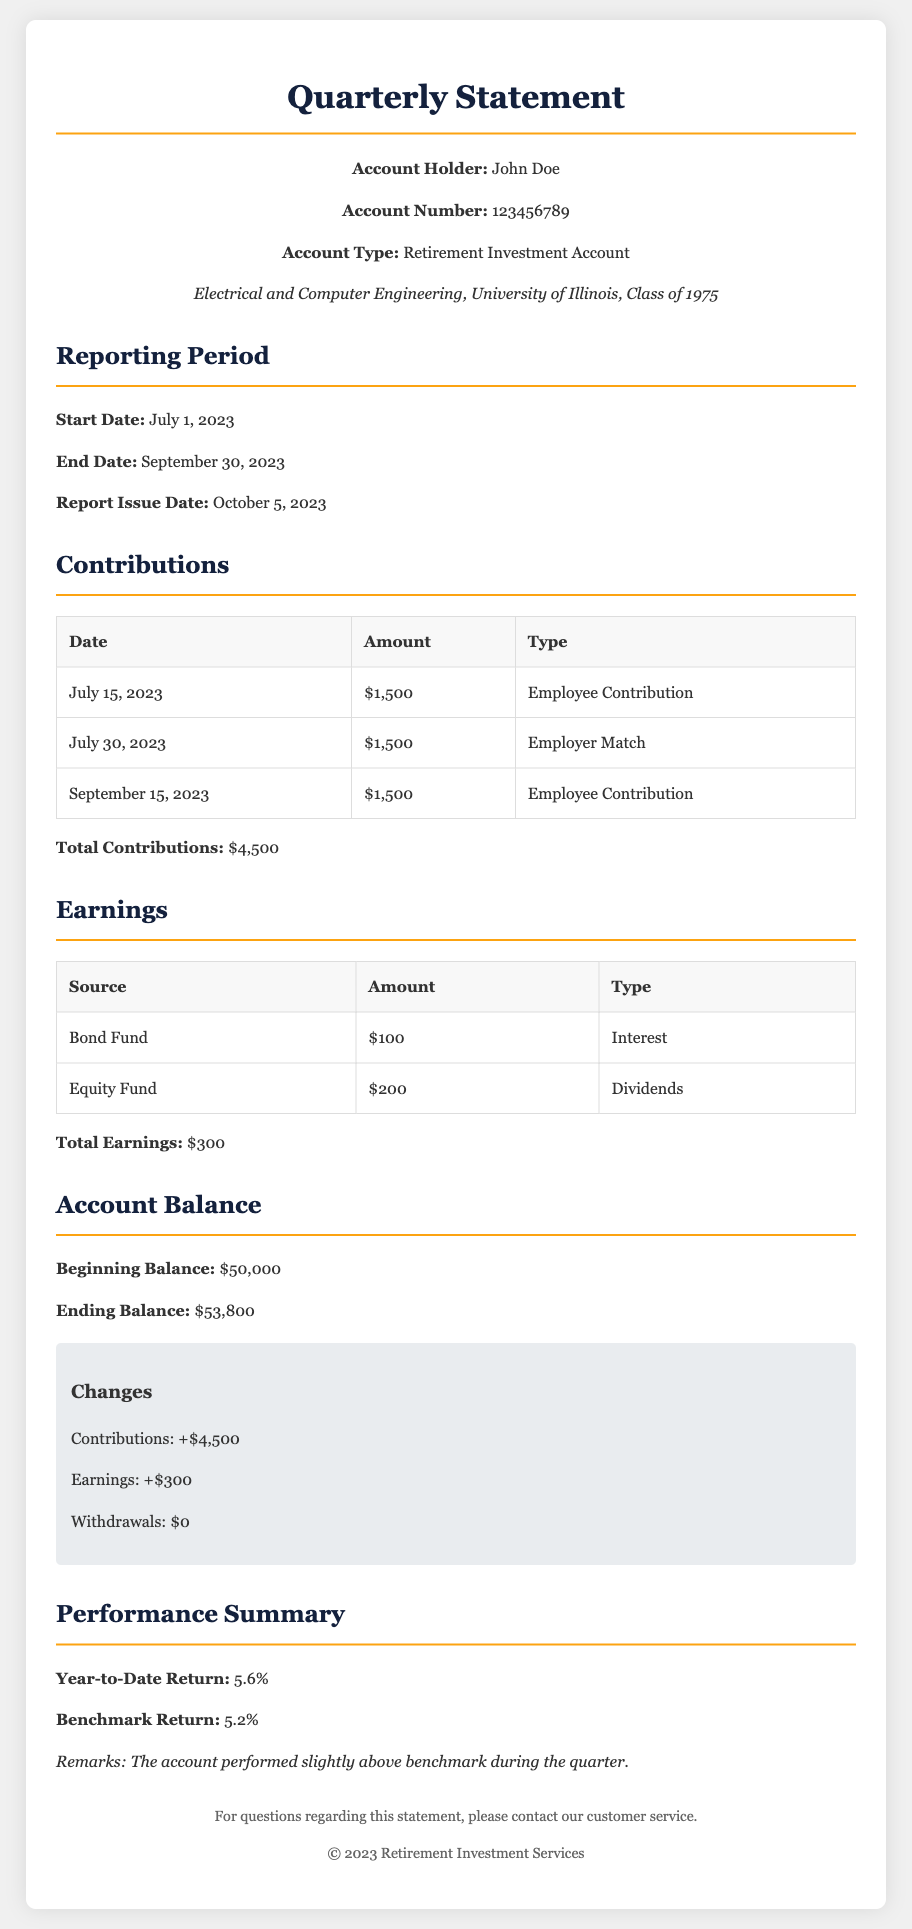What is the account holder's name? The account holder's name is listed prominently in the document as John Doe.
Answer: John Doe What is the total contributions amount? The document summarizes contributions and indicates the total contributions as $4,500.
Answer: $4,500 What is the beginning balance of the account? The beginning balance is stated in the account balance section, which is $50,000.
Answer: $50,000 What is the year-to-date return percentage? The year-to-date return is explicitly mentioned in the performance summary as 5.6%.
Answer: 5.6% How much was earned from the equity fund? The earning from the equity fund is detailed and amounts to $200.
Answer: $200 What date does the reporting period start? The start date of the reporting period is clearly specified as July 1, 2023.
Answer: July 1, 2023 What is the total earnings from all sources? The total earnings are specifically summarized as $300 in the earnings section.
Answer: $300 How much did the account balance increase during this period? The increase in the account balance can be calculated by subtracting the beginning balance from the ending balance, which shows an increase of $3,800.
Answer: $3,800 What type of account is this statement for? The document identifies the account type as a Retirement Investment Account.
Answer: Retirement Investment Account 